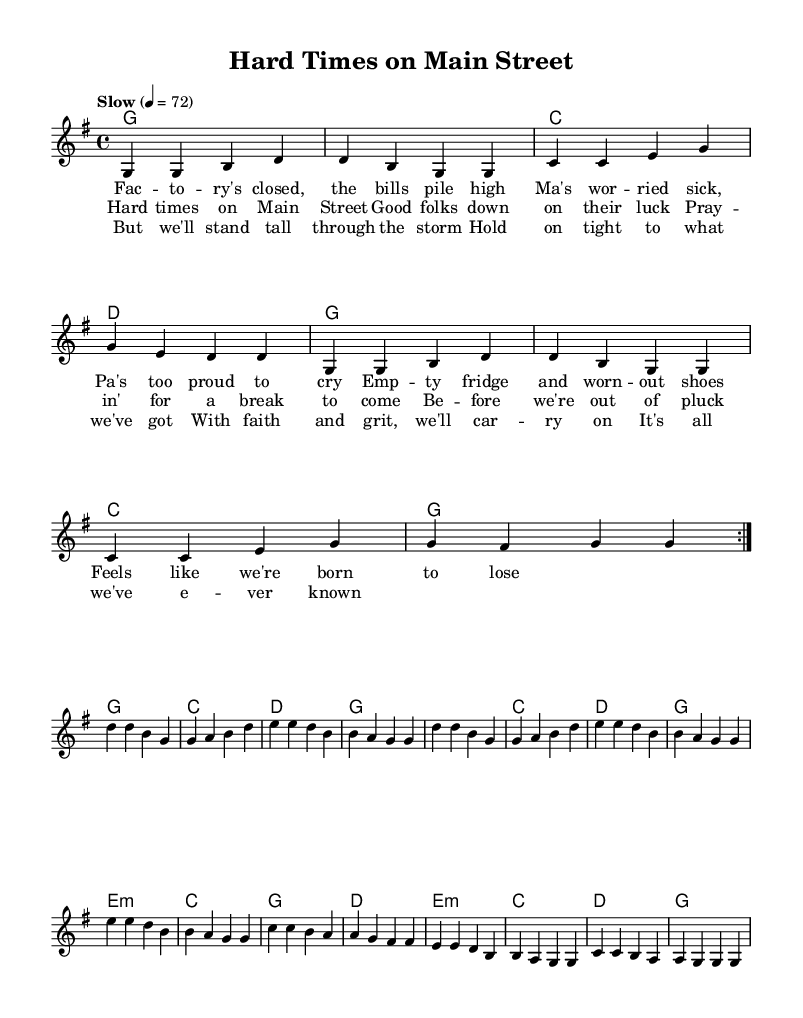What is the key signature of this music? The key signature indicates that the piece is in G major, which has one sharp (F#). It can be identified from the initial part of the sheet music that indicates the key.
Answer: G major What is the time signature of this music? The time signature is 4/4, which shows that there are four beats in a measure and the quarter note gets one beat. This is clearly noted in the beginning of the score.
Answer: 4/4 What is the tempo marking for this piece? The tempo marking is "Slow" at a value of 72 beats per minute, indicating that the music should be played at a slow pace. This is stated prominently above the staff.
Answer: Slow 4 = 72 How many verses are in the lyrics? The lyrics include one verse, a chorus, and a bridge, all of which provide the structure of the song. Counting these sections gives a total of one verse.
Answer: One What kind of themes are presented in the lyrics? The themes presented in the lyrics involve economic struggles and perseverance during hard times, typical of working-class narratives in country music. This can be inferred from the content of the lyrics included with the melody.
Answer: Economic struggles What musical form does this song follow? The song follows a verse-chorus-bridge form, which is a common structure in country ballads. This is evident from the layout and arrangement of the lyrics within the score.
Answer: Verse-Chorus-Bridge What do the lyrics suggest about the family's situation? The lyrics suggest that the family is facing financial hardships and emotional stress due to job loss and an empty fridge, highlighting the struggles of working-class families. This can be determined by analyzing the themes within the lyrics.
Answer: Financial hardships 